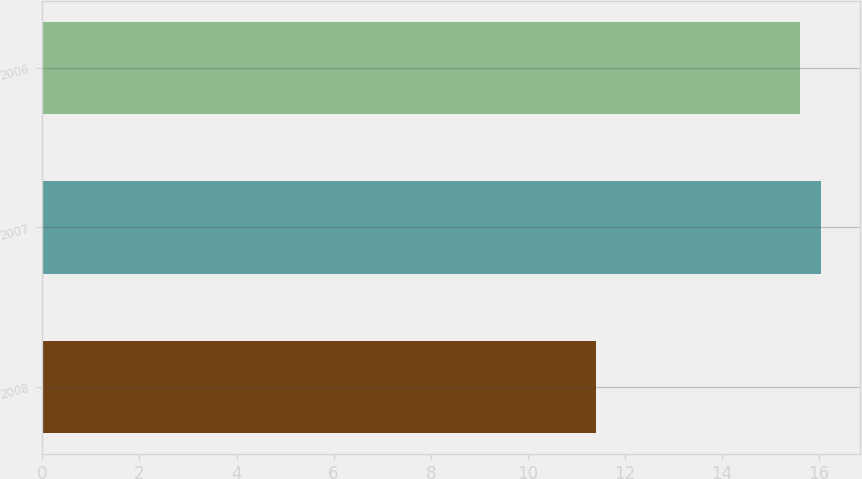Convert chart to OTSL. <chart><loc_0><loc_0><loc_500><loc_500><bar_chart><fcel>2008<fcel>2007<fcel>2006<nl><fcel>11.4<fcel>16.05<fcel>15.6<nl></chart> 